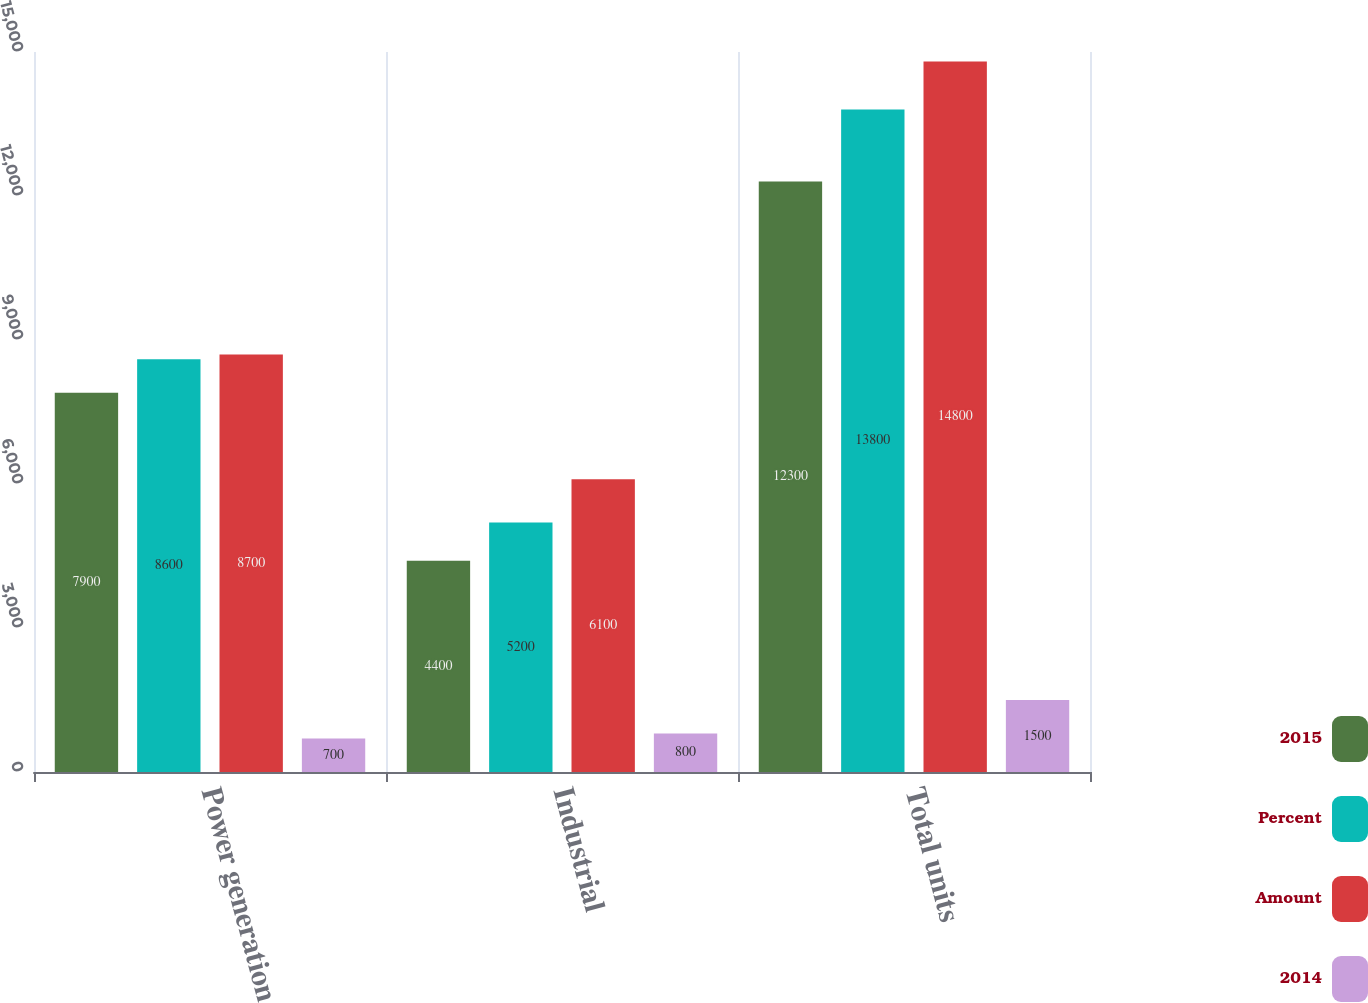<chart> <loc_0><loc_0><loc_500><loc_500><stacked_bar_chart><ecel><fcel>Power generation<fcel>Industrial<fcel>Total units<nl><fcel>2015<fcel>7900<fcel>4400<fcel>12300<nl><fcel>Percent<fcel>8600<fcel>5200<fcel>13800<nl><fcel>Amount<fcel>8700<fcel>6100<fcel>14800<nl><fcel>2014<fcel>700<fcel>800<fcel>1500<nl></chart> 